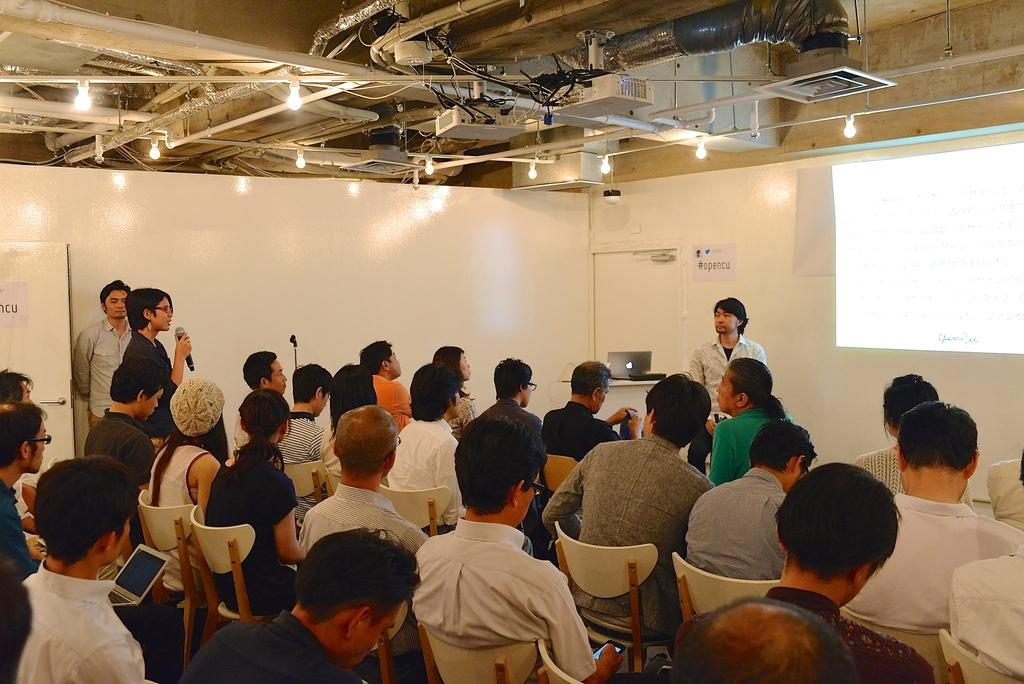What are the people in the image doing? The people in the image are sitting on chairs. What electronic device can be seen in the image? There is a laptop in the image. What type of structure is visible in the image? There is a wall in the image. Is there a volleyball game happening in the image? No, there is no volleyball game present in the image. What direction are the people facing in the image? The provided facts do not give information about the direction the people are facing, so it cannot be determined from the image. 